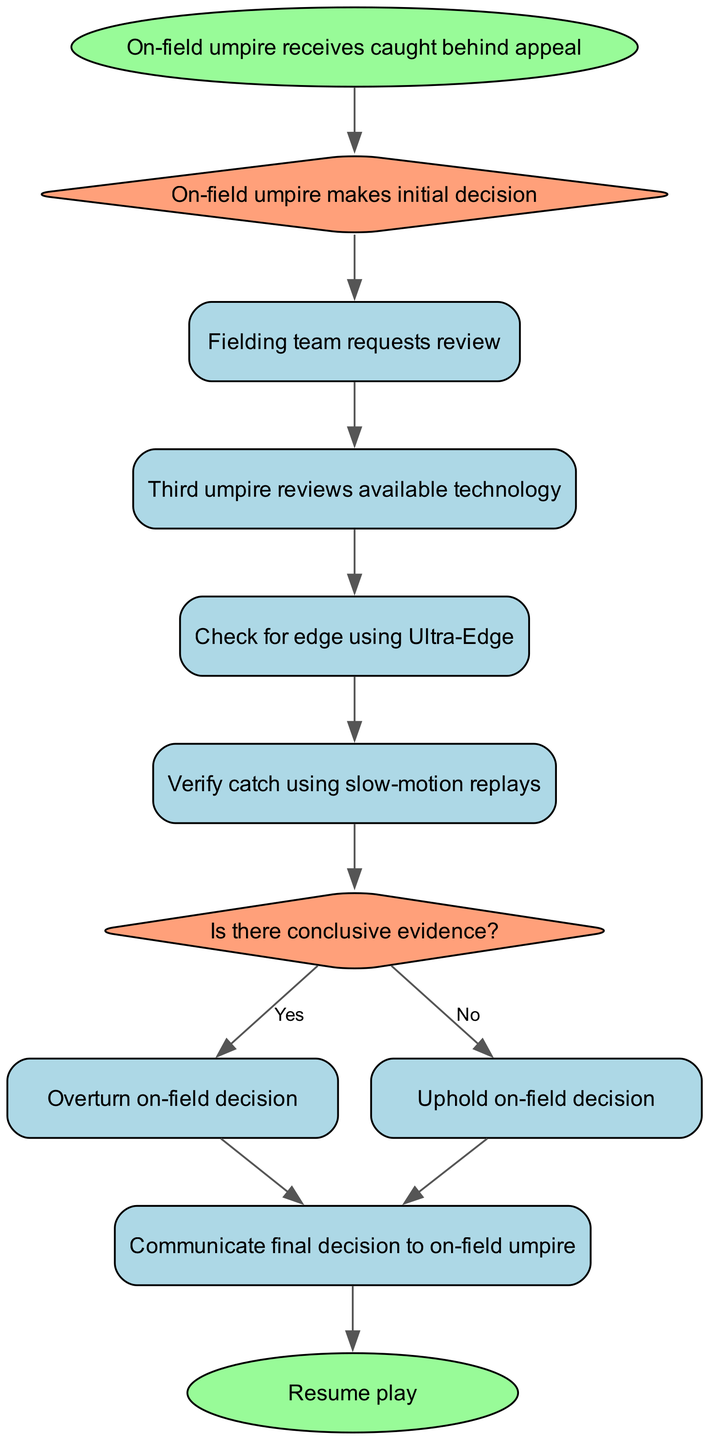What is the first action in the flow chart? The first node in the flow chart is labeled "On-field umpire receives caught behind appeal," which indicates the starting point of the decision-making process.
Answer: On-field umpire receives caught behind appeal How many nodes are in the diagram? Counting each distinct element in the provided data, there are a total of 11 nodes, including both the start and end points, as well as all decision points.
Answer: 11 What is the final step indicated in the process? The last step or node before the process concludes is labeled "Resume play," which indicates the termination of the decision-making process and the resumption of the game.
Answer: Resume play What decision point does the process check for after using slow-motion replays? After the node labeled "Verify catch using slow-motion replays," the next decision point is "Is there conclusive evidence?" indicating a crucial evaluation step in the process.
Answer: Is there conclusive evidence? What happens if there is conclusive evidence? If the answer to "Is there conclusive evidence?" is "Yes," the process flows to the node "Overturn on-field decision," indicating that the initial decision will be changed based on the evidence.
Answer: Overturn on-field decision Which two actions occur before communicating the final decision? The actions that occur immediately before "Communicate final decision to on-field umpire" are either "Overturn on-field decision" or "Uphold on-field decision," depending on the evidence reviewed.
Answer: Overturn on-field decision or Uphold on-field decision What is the role of the third umpire in this process? The third umpire's role, as indicated in the flow chart, is to "review available technology," which includes examining evidence for the caught behind appeal using advanced tools.
Answer: Review available technology What is required for the initial decision to be upheld? The process requires that there is "No" conclusive evidence for the initial appeal decision to be upheld according to the decision flow.
Answer: No What technology is checked first when reviewing a caught behind appeal? The first technology utilized in the review process is "Ultra-Edge," which is specifically used to check for any edge made by the bat on the ball.
Answer: Ultra-Edge 